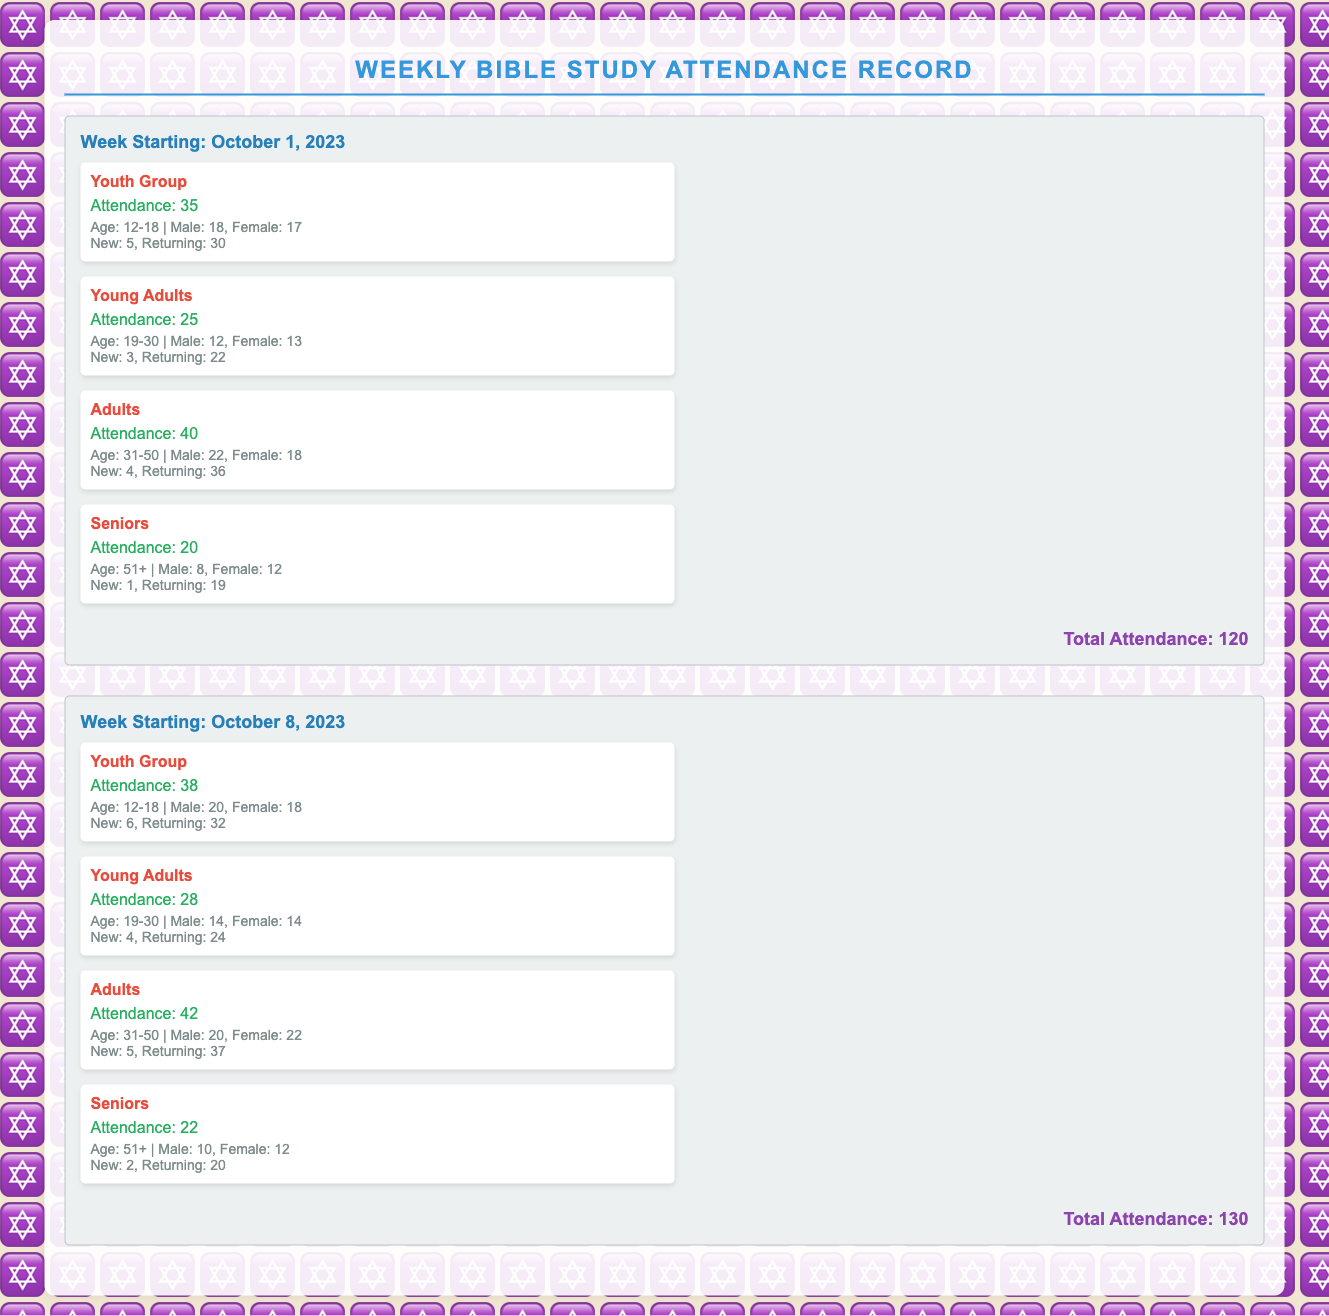what is the total attendance for the week starting October 1, 2023? The total attendance for this week is mentioned at the bottom of the section, which is 120.
Answer: 120 how many new attendees were in the Young Adults group for the week starting October 8, 2023? The document shows the number of new attendees for the Young Adults group in that week, which is 4.
Answer: 4 what is the gender distribution of the Youth Group on October 1, 2023? The document specifies that in the Youth Group on this date, there are 18 males and 17 females.
Answer: 18 males, 17 females which group had the highest attendance during the week starting October 8, 2023? The section for October 8, 2023 provides the attendance numbers, and the Adults group had the highest attendance with 42.
Answer: Adults how many total attendees were returning for the Seniors group in the week starting October 1, 2023? In the document, it states that the returning attendees for the Seniors group in that week were 19.
Answer: 19 what age group does the Adults group represent? The demographics section for the Adults group indicates their age range as 31-50.
Answer: 31-50 which group saw an increase in attendance from October 1 to October 8, 2023? By comparing the attendance numbers from both weeks in the document, the Youth Group had an increase from 35 to 38.
Answer: Youth Group how many females attended the Seniors group for the week starting October 8, 2023? The demographic information for the Seniors group shows that there were 12 females attending on this date.
Answer: 12 